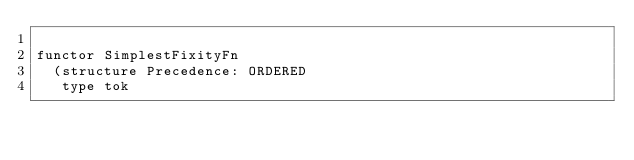Convert code to text. <code><loc_0><loc_0><loc_500><loc_500><_SML_>
functor SimplestFixityFn 
  (structure Precedence: ORDERED
   type tok </code> 